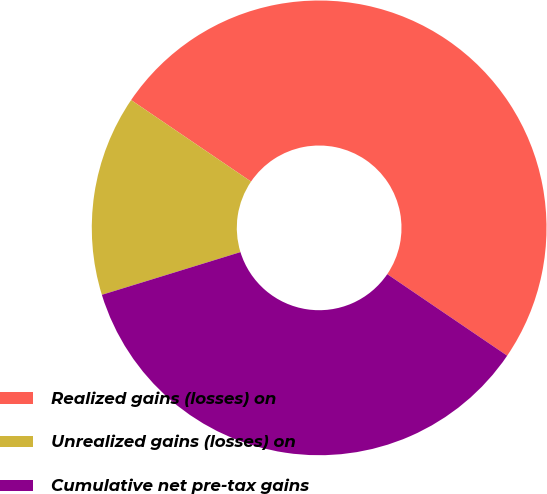Convert chart to OTSL. <chart><loc_0><loc_0><loc_500><loc_500><pie_chart><fcel>Realized gains (losses) on<fcel>Unrealized gains (losses) on<fcel>Cumulative net pre-tax gains<nl><fcel>50.0%<fcel>14.26%<fcel>35.74%<nl></chart> 